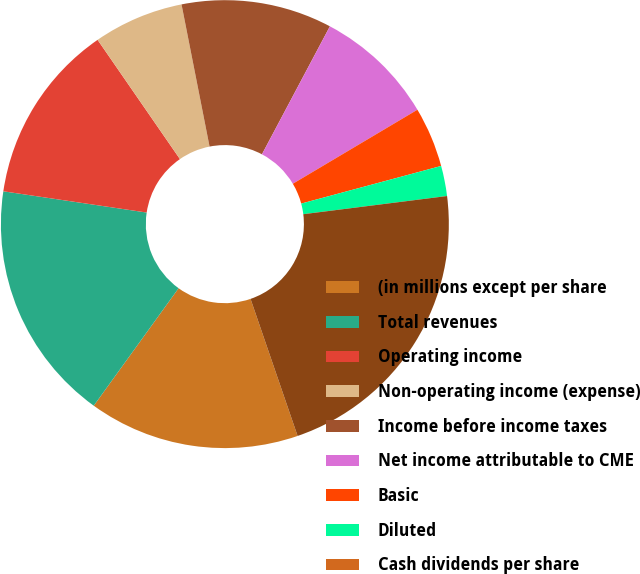Convert chart. <chart><loc_0><loc_0><loc_500><loc_500><pie_chart><fcel>(in millions except per share<fcel>Total revenues<fcel>Operating income<fcel>Non-operating income (expense)<fcel>Income before income taxes<fcel>Net income attributable to CME<fcel>Basic<fcel>Diluted<fcel>Cash dividends per share<fcel>Total assets<nl><fcel>15.22%<fcel>17.39%<fcel>13.04%<fcel>6.52%<fcel>10.87%<fcel>8.7%<fcel>4.35%<fcel>2.18%<fcel>0.0%<fcel>21.74%<nl></chart> 